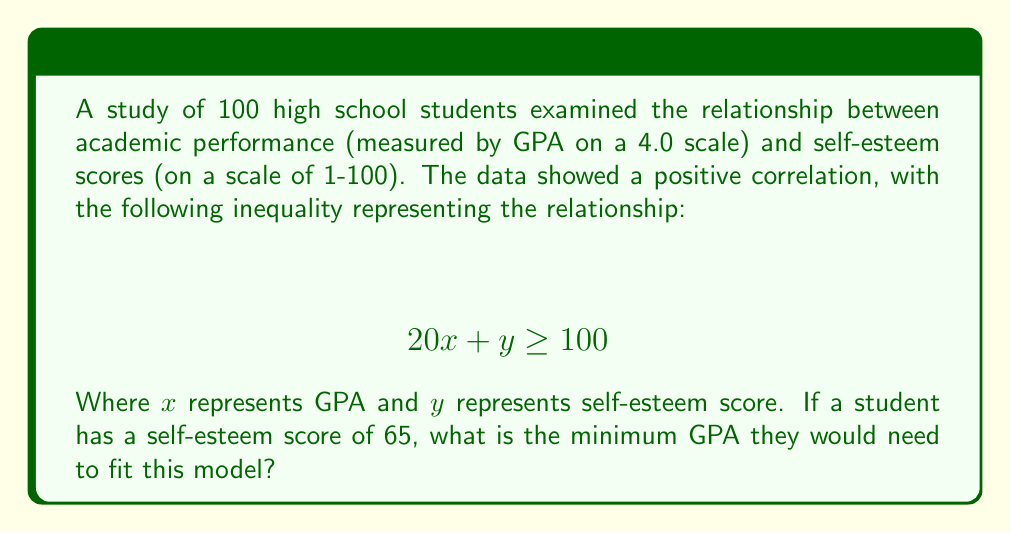What is the answer to this math problem? Let's approach this step-by-step:

1) We start with the inequality:
   $$ 20x + y \geq 100 $$

2) We know the student's self-esteem score (y) is 65. Let's substitute this:
   $$ 20x + 65 \geq 100 $$

3) To isolate x (GPA), first subtract 65 from both sides:
   $$ 20x \geq 35 $$

4) Now, divide both sides by 20:
   $$ x \geq \frac{35}{20} = 1.75 $$

5) Since GPA is typically reported to two decimal places, we round up to ensure the inequality is satisfied:
   $$ x \geq 1.75 $$

Therefore, the minimum GPA needed is 1.75.
Answer: 1.75 